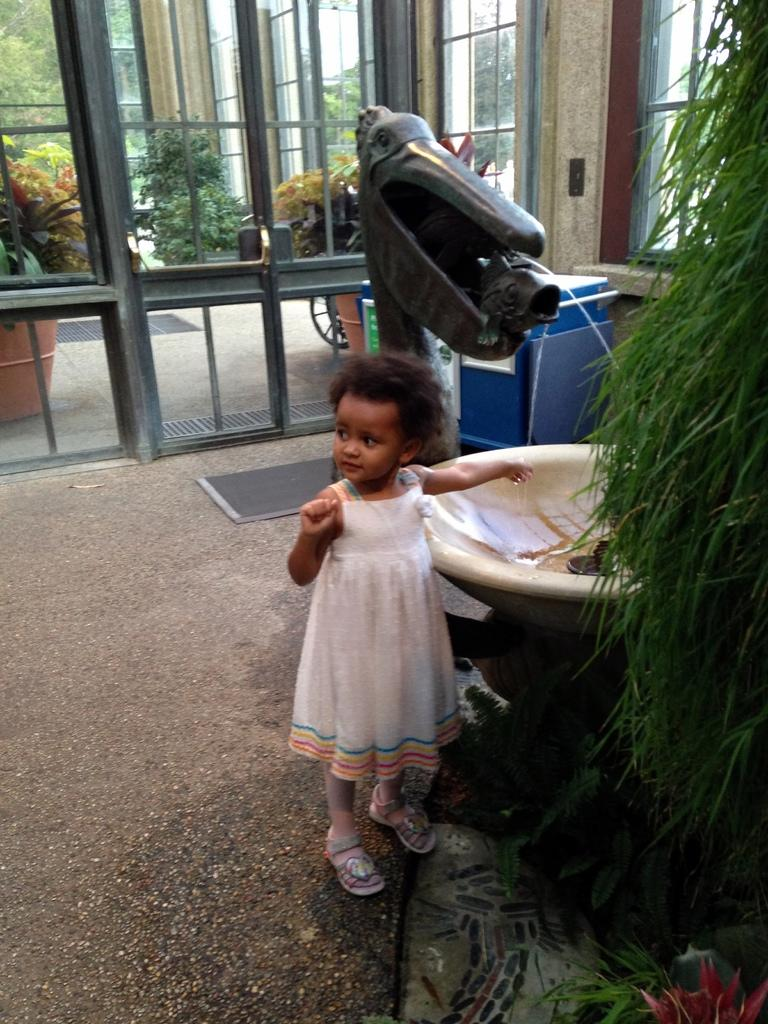Who is the main subject in the image? There is a girl in the image. What is the girl wearing? The girl is wearing a white dress. What type of surface is visible in the image? There is a floor visible in the image. What other object can be seen in the image? There is a plant in the image. What architectural feature is visible in the background? There are doors in the background of the image. What news is the girl reading in the image? There is no newspaper or any news visible in the image. 